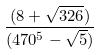Convert formula to latex. <formula><loc_0><loc_0><loc_500><loc_500>\frac { ( 8 + \sqrt { 3 2 6 } ) } { ( 4 7 0 ^ { 5 } - \sqrt { 5 } ) }</formula> 